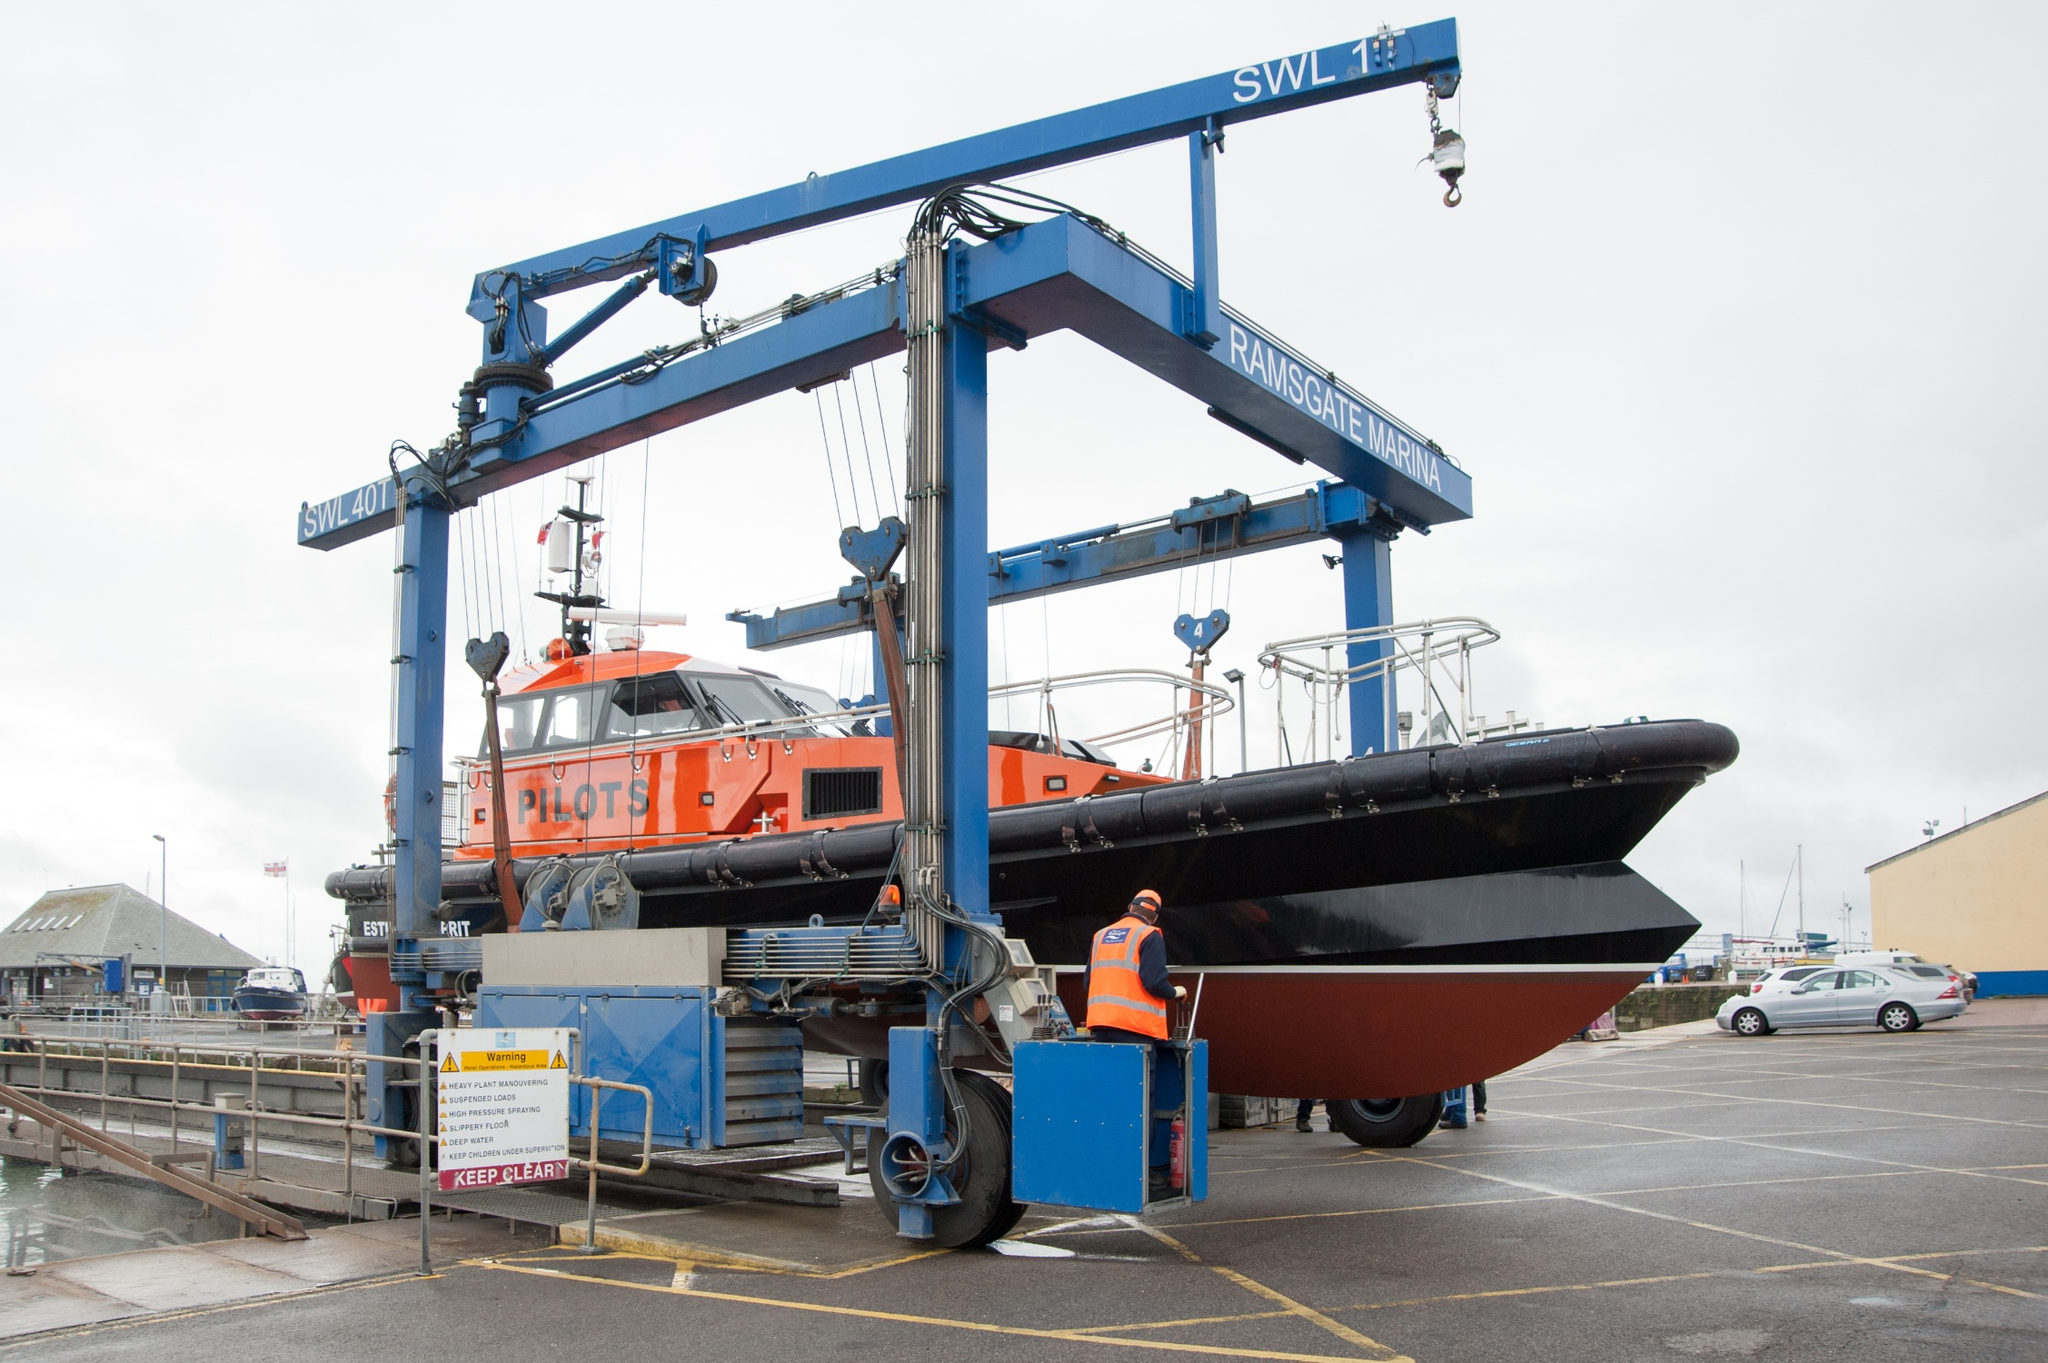What details can you provide about the pilot boat in the image? The pilot boat, marked visibly with 'PILOTS', serves a crucial role in maritime navigation. It carries maritime pilots between land and the inbound or outbound ships they are piloting. This specific boat is equipped with advanced navigation tools and has a robust design to handle the challenging conditions at sea. The orange and black color scheme not only adds to its visibility in various weather conditions but also signifies the importance of its function. 